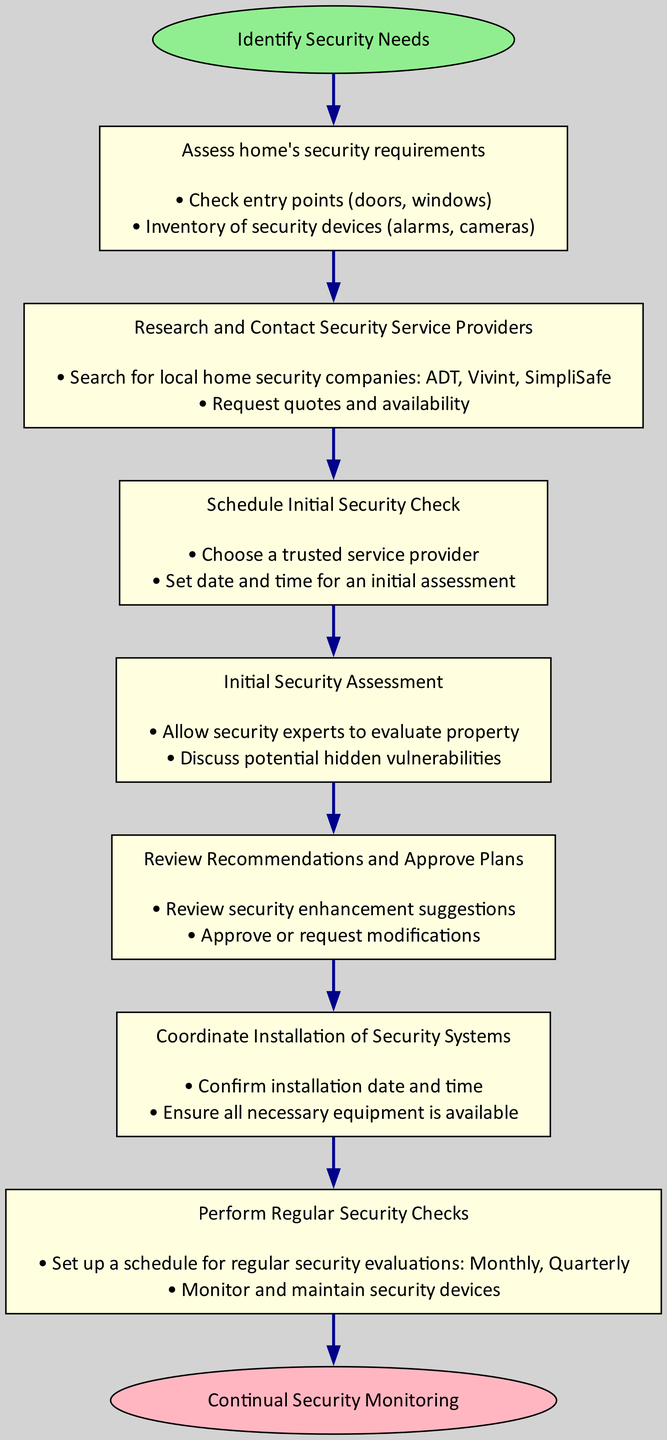What is the first step in the process? The first step, as indicated by the flowchart, is "Assess home's security requirements". This is directly connected to the "Start" node.
Answer: Assess home's security requirements How many steps are there in total? The flowchart outlines a total of 7 steps following the initial "Identify Security Needs" node. This includes from Step 1 to Step 7.
Answer: 7 What actions are included in the third step? The third step involves actions such as "Choose a trusted service provider" and "Set date and time for an initial assessment". These actions define what needs to be done in this step.
Answer: Choose a trusted service provider, Set date and time for an initial assessment Which step discusses potential hidden vulnerabilities? The step that discusses potential hidden vulnerabilities is "Initial Security Assessment". This step involves allowing experts to evaluate the property and discussing vulnerabilities.
Answer: Initial Security Assessment What is the final outcome of the process? The final outcome of the process as stated in the flowchart is "Continual Security Monitoring", which follows after performing regular security checks in Step 7.
Answer: Continual Security Monitoring How are the steps connected in the flowchart? The steps are connected in a sequential manner, starting from "Identify Security Needs" to the final "End" node. Each step leads to the next in a linear progression without any branches or loops.
Answer: Sequentially In which step do you review recommendations? You review recommendations in "Review Recommendations and Approve Plans", which is identified as Step 5 in the flowchart.
Answer: Review Recommendations and Approve Plans What must be confirmed in Step 6? In Step 6, you must "Confirm installation date and time" as part of coordinating the installation of security systems. This ensures that everything is ready for the installation.
Answer: Confirm installation date and time 